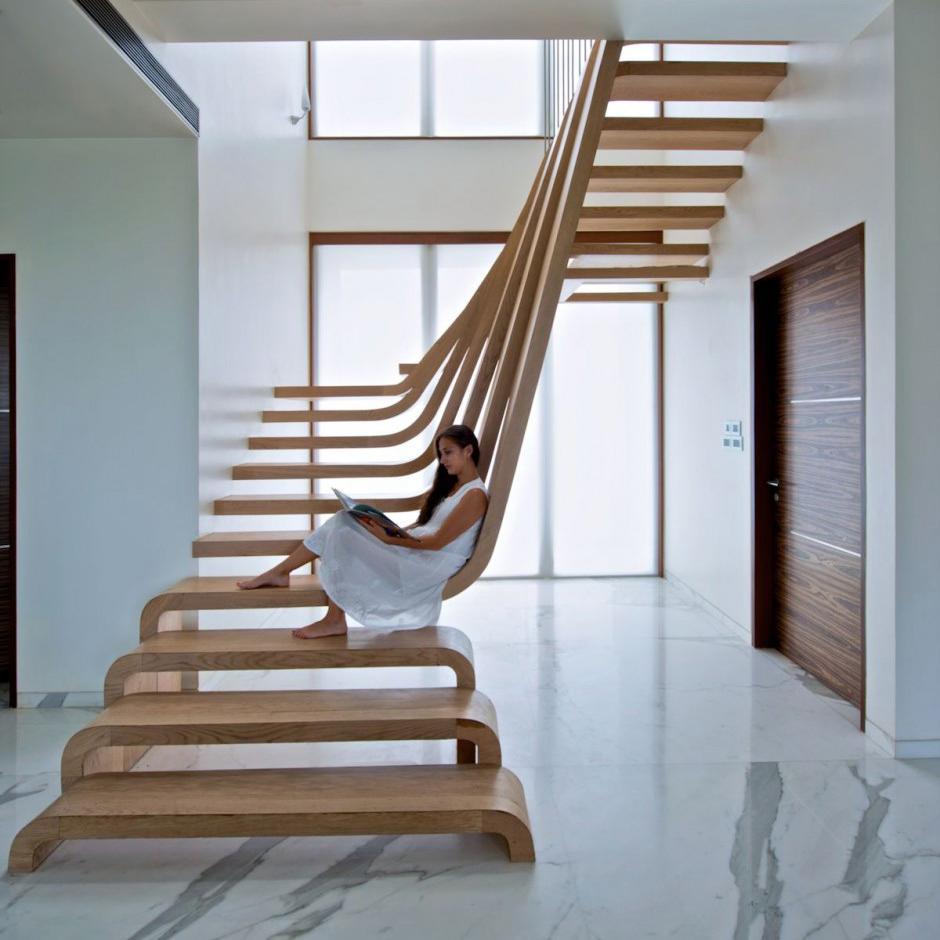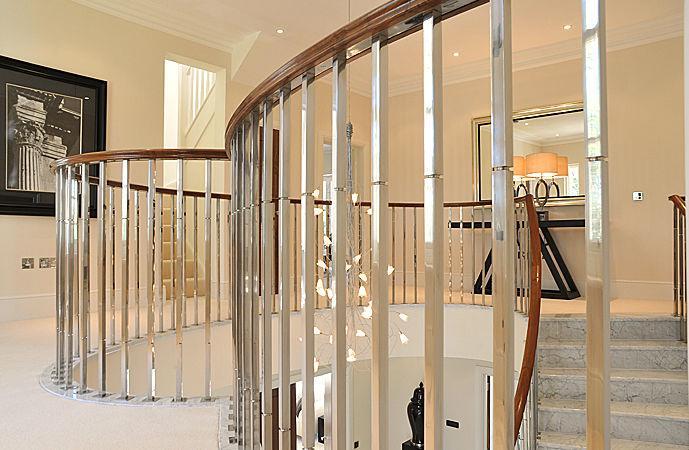The first image is the image on the left, the second image is the image on the right. Analyze the images presented: Is the assertion "The left image shows a staircase that ascends rightward without turning and has an enclosed side and baseboards, a brown wood handrail, and vertical metal bars." valid? Answer yes or no. No. 